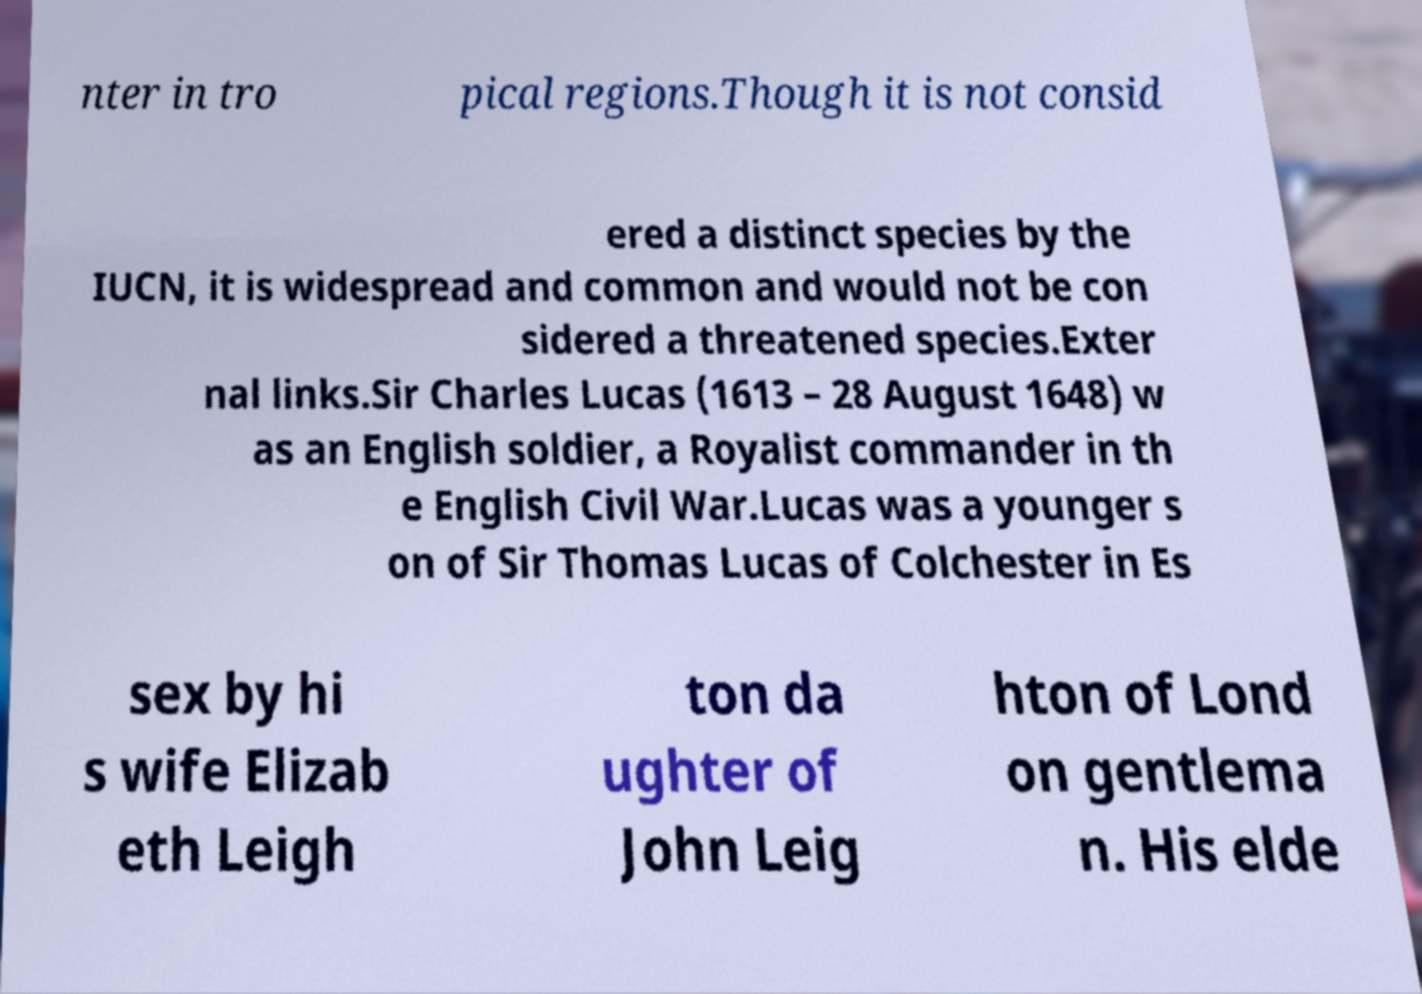I need the written content from this picture converted into text. Can you do that? nter in tro pical regions.Though it is not consid ered a distinct species by the IUCN, it is widespread and common and would not be con sidered a threatened species.Exter nal links.Sir Charles Lucas (1613 – 28 August 1648) w as an English soldier, a Royalist commander in th e English Civil War.Lucas was a younger s on of Sir Thomas Lucas of Colchester in Es sex by hi s wife Elizab eth Leigh ton da ughter of John Leig hton of Lond on gentlema n. His elde 